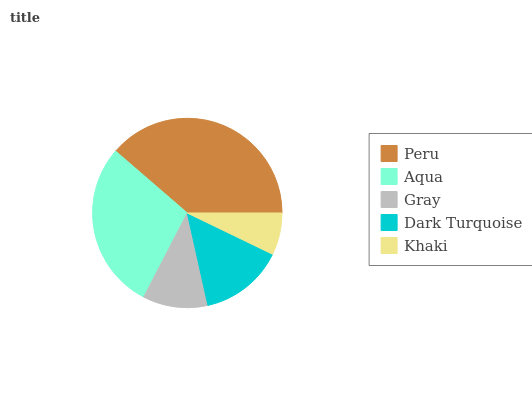Is Khaki the minimum?
Answer yes or no. Yes. Is Peru the maximum?
Answer yes or no. Yes. Is Aqua the minimum?
Answer yes or no. No. Is Aqua the maximum?
Answer yes or no. No. Is Peru greater than Aqua?
Answer yes or no. Yes. Is Aqua less than Peru?
Answer yes or no. Yes. Is Aqua greater than Peru?
Answer yes or no. No. Is Peru less than Aqua?
Answer yes or no. No. Is Dark Turquoise the high median?
Answer yes or no. Yes. Is Dark Turquoise the low median?
Answer yes or no. Yes. Is Peru the high median?
Answer yes or no. No. Is Peru the low median?
Answer yes or no. No. 